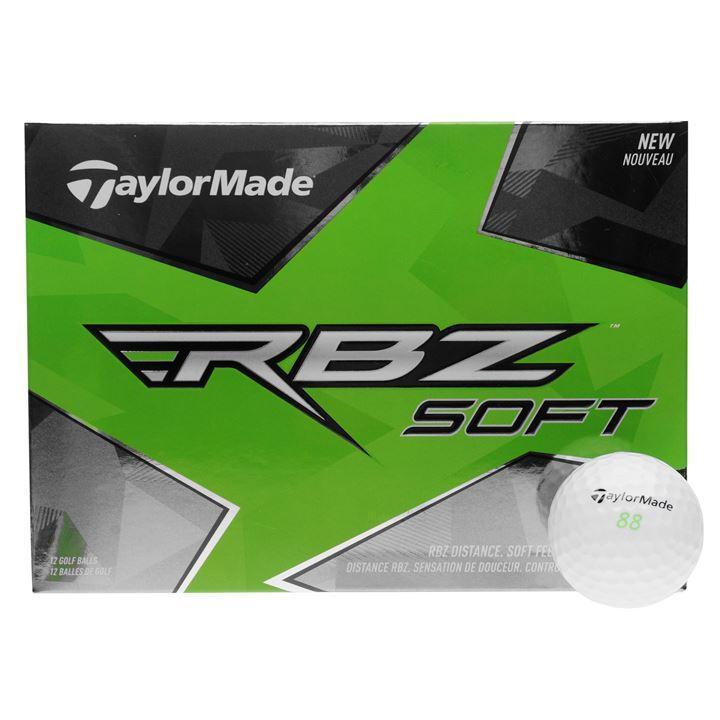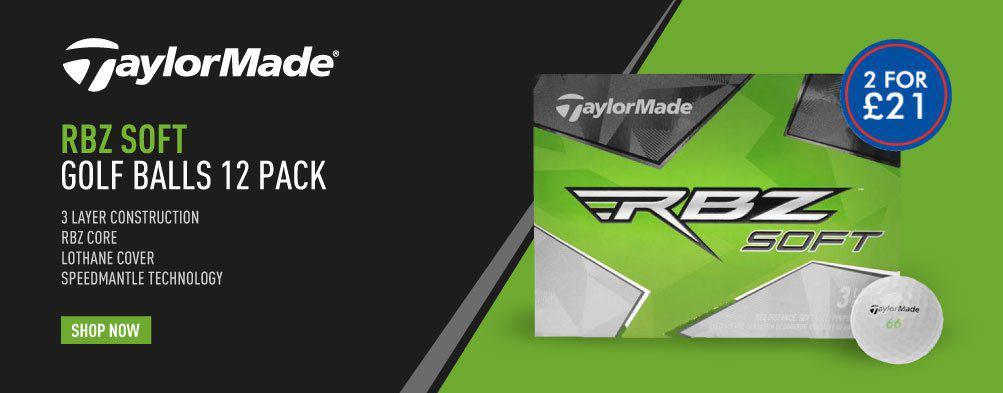The first image is the image on the left, the second image is the image on the right. Given the left and right images, does the statement "The left image shows a box with """"RBZ SOFT"""" shown on it." hold true? Answer yes or no. Yes. 